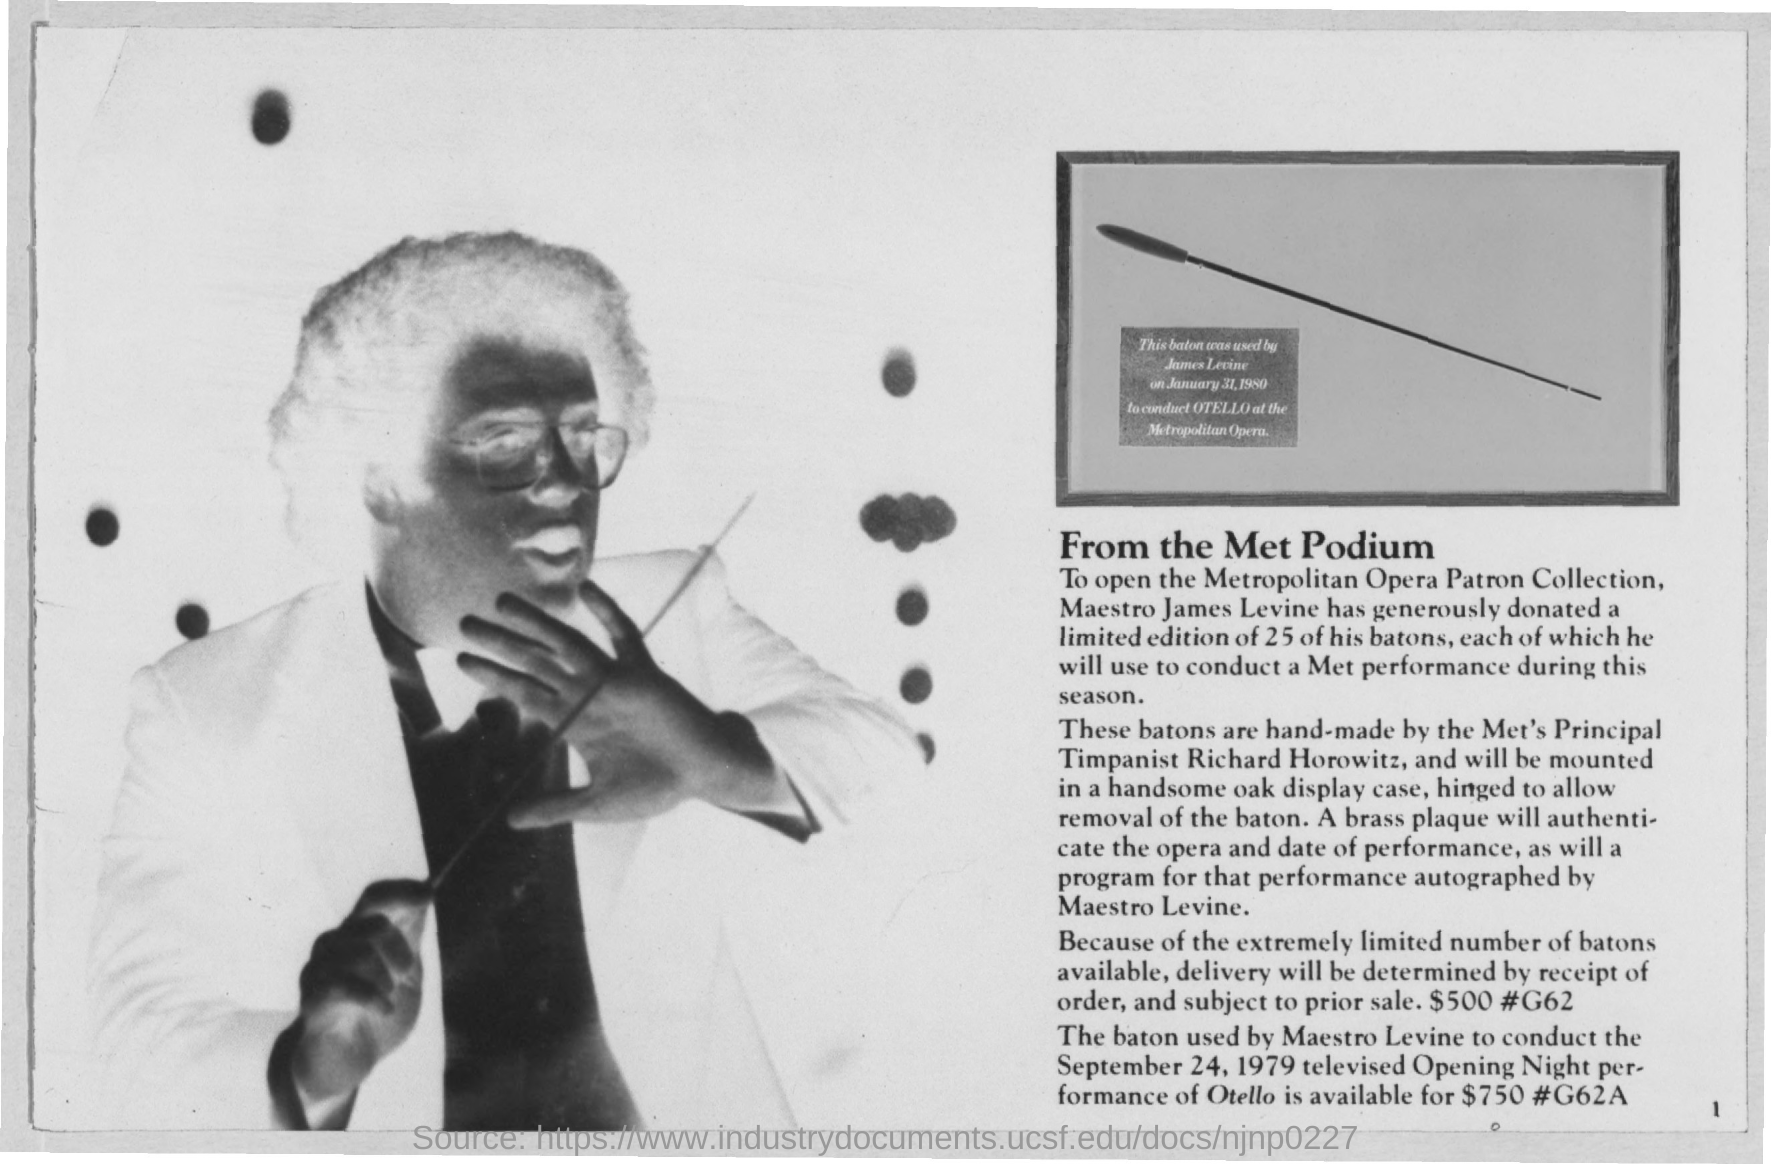Indicate a few pertinent items in this graphic. The price of the baton used by Maestro Levine is $750. Richard Horowitz is the principal timpanist of the Metropolitan Opera. 